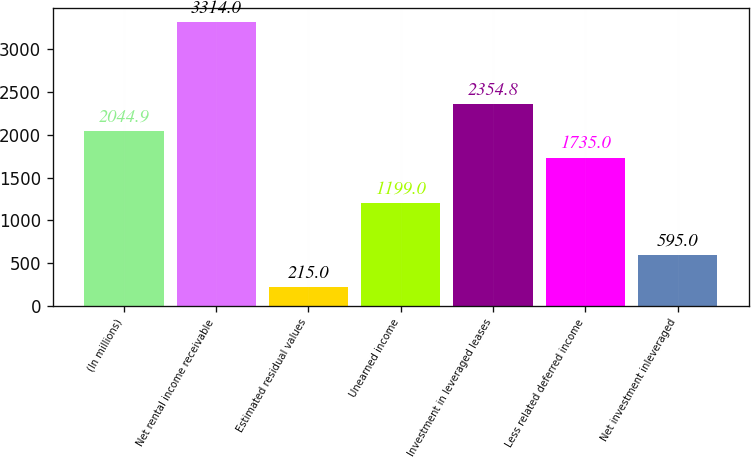<chart> <loc_0><loc_0><loc_500><loc_500><bar_chart><fcel>(In millions)<fcel>Net rental income receivable<fcel>Estimated residual values<fcel>Unearned income<fcel>Investment in leveraged leases<fcel>Less related deferred income<fcel>Net investment inleveraged<nl><fcel>2044.9<fcel>3314<fcel>215<fcel>1199<fcel>2354.8<fcel>1735<fcel>595<nl></chart> 